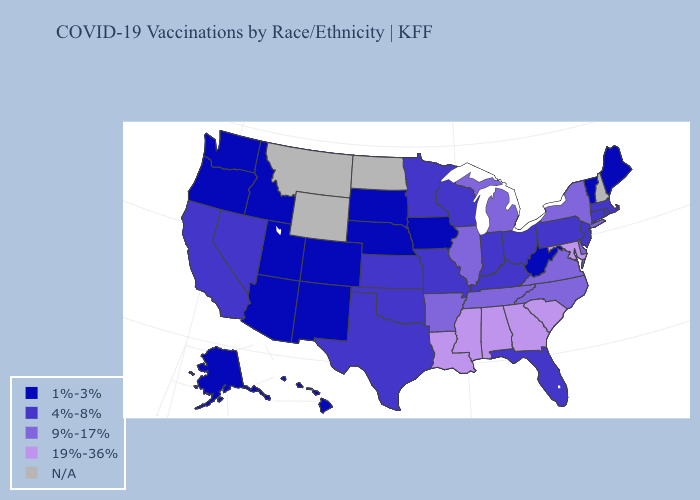What is the value of Rhode Island?
Quick response, please. 4%-8%. Does Pennsylvania have the lowest value in the USA?
Give a very brief answer. No. Among the states that border Massachusetts , which have the highest value?
Answer briefly. New York. What is the highest value in the USA?
Give a very brief answer. 19%-36%. What is the value of Massachusetts?
Short answer required. 4%-8%. Name the states that have a value in the range 9%-17%?
Give a very brief answer. Arkansas, Delaware, Illinois, Michigan, New York, North Carolina, Tennessee, Virginia. What is the value of Utah?
Keep it brief. 1%-3%. Among the states that border South Dakota , does Iowa have the highest value?
Answer briefly. No. What is the lowest value in the USA?
Keep it brief. 1%-3%. What is the highest value in states that border Maryland?
Quick response, please. 9%-17%. Which states hav the highest value in the MidWest?
Concise answer only. Illinois, Michigan. What is the value of Utah?
Write a very short answer. 1%-3%. 